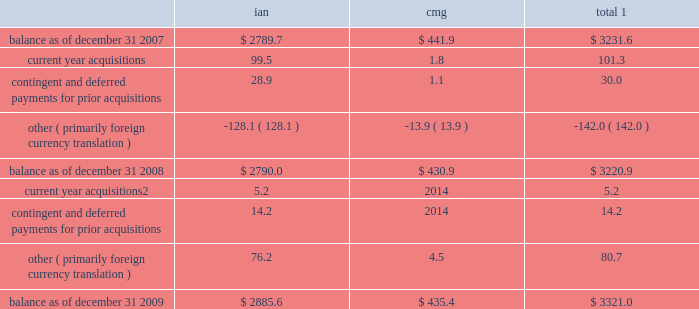Notes to consolidated financial statements 2014 ( continued ) ( amounts in millions , except per share amounts ) sales of businesses and investments 2013 primarily includes realized gains and losses relating to the sales of businesses , cumulative translation adjustment balances from the liquidation of entities and sales of marketable securities and investments in publicly traded and privately held companies in our rabbi trusts .
During 2009 , we realized a gain of $ 15.2 related to the sale of an investment in our rabbi trusts , which was partially offset by losses realized from the sale of various businesses .
Losses in 2007 primarily related to the sale of several businesses within draftfcb for a loss of $ 9.3 and charges at lowe of $ 7.8 as a result of the realization of cumulative translation adjustment balances from the liquidation of several businesses .
Vendor discounts and credit adjustments 2013 we are in the process of settling our liabilities related to vendor discounts and credits established during the restatement we presented in our 2004 annual report on form 10-k .
These adjustments reflect the reversal of certain of these liabilities as a result of settlements with clients or vendors or where the statute of limitations has lapsed .
Litigation settlement 2013 during may 2008 , the sec concluded its investigation that began in 2002 into our financial reporting practices , resulting in a settlement charge of $ 12.0 .
Investment impairments 2013 in 2007 we realized an other-than-temporary charge of $ 5.8 relating to a $ 12.5 investment in auction rate securities , representing our total investment in auction rate securities .
See note 12 for further information .
Note 5 : intangible assets goodwill goodwill is the excess purchase price remaining from an acquisition after an allocation of purchase price has been made to identifiable assets acquired and liabilities assumed based on estimated fair values .
The changes in the carrying value of goodwill for our segments , integrated agency networks ( 201cian 201d ) and constituency management group ( 201ccmg 201d ) , for the years ended december 31 , 2009 and 2008 are listed below. .
1 for all periods presented we have not recorded a goodwill impairment charge .
2 for acquisitions completed after january 1 , 2009 , amount includes contingent and deferred payments , which are recorded at fair value on the acquisition date .
See note 6 for further information .
See note 1 for further information regarding our annual impairment methodology .
Other intangible assets included in other intangible assets are assets with indefinite lives not subject to amortization and assets with definite lives subject to amortization .
Other intangible assets primarily include customer lists and trade names .
Intangible assets with definitive lives subject to amortization are amortized on a straight-line basis with estimated useful lives generally between 7 and 15 years .
Amortization expense for other intangible assets for the years ended december 31 , 2009 , 2008 and 2007 was $ 19.3 , $ 14.4 and $ 8.5 , respectively .
The following table provides a summary of other intangible assets , which are included in other assets on our consolidated balance sheets. .
In 2007 what was the percent of the investment impairments to the investment in auction rate securities? 
Computations: (5.8 / 12.5)
Answer: 0.464. 